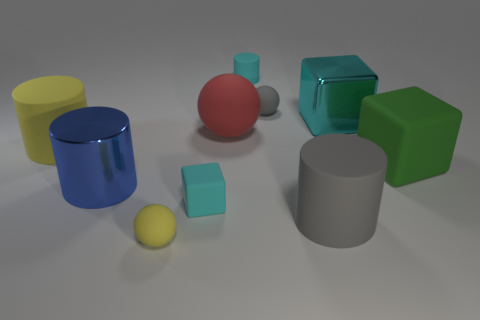There is a red ball that is the same size as the green matte object; what is it made of?
Your response must be concise. Rubber. Are there more rubber objects in front of the big green object than big matte spheres that are to the right of the big cyan block?
Make the answer very short. Yes. Is there another large metal thing that has the same shape as the green object?
Ensure brevity in your answer.  Yes. There is a yellow object that is the same size as the metallic cylinder; what shape is it?
Offer a terse response. Cylinder. What shape is the cyan matte object that is behind the large shiny block?
Keep it short and to the point. Cylinder. Is the number of big gray cylinders that are behind the big blue object less than the number of cubes that are in front of the yellow cylinder?
Keep it short and to the point. Yes. There is a gray rubber cylinder; is its size the same as the matte cube that is behind the big blue object?
Provide a succinct answer. Yes. How many gray cylinders have the same size as the red object?
Provide a succinct answer. 1. What is the color of the other block that is made of the same material as the tiny cube?
Your answer should be very brief. Green. Are there more yellow things than tiny cyan metal objects?
Your answer should be very brief. Yes. 